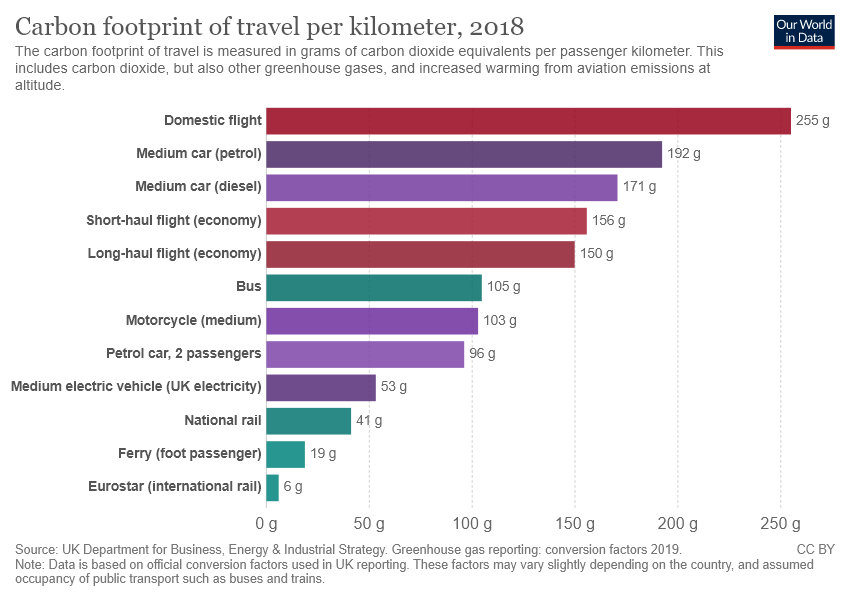Give some essential details in this illustration. The longest bar in the histogram represents domestic flights, where the height of the bar indicates the number of occurrences of that category. The value of national rail and bus is currently 64. 